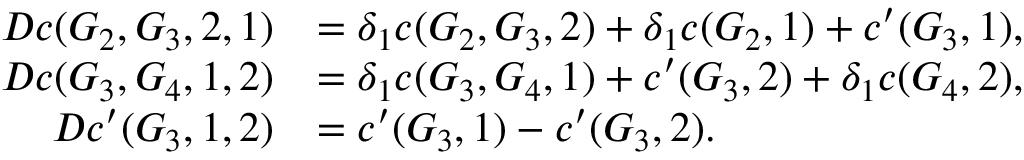Convert formula to latex. <formula><loc_0><loc_0><loc_500><loc_500>\begin{array} { r l } { D c ( G _ { 2 } , G _ { 3 } , 2 , 1 ) } & { = \delta _ { 1 } c ( G _ { 2 } , G _ { 3 } , 2 ) + \delta _ { 1 } c ( G _ { 2 } , 1 ) + c ^ { \prime } ( G _ { 3 } , 1 ) , } \\ { D c ( G _ { 3 } , G _ { 4 } , 1 , 2 ) } & { = \delta _ { 1 } c ( G _ { 3 } , G _ { 4 } , 1 ) + c ^ { \prime } ( G _ { 3 } , 2 ) + \delta _ { 1 } c ( G _ { 4 } , 2 ) , } \\ { D c ^ { \prime } ( G _ { 3 } , 1 , 2 ) } & { = c ^ { \prime } ( G _ { 3 } , 1 ) - c ^ { \prime } ( G _ { 3 } , 2 ) . } \end{array}</formula> 